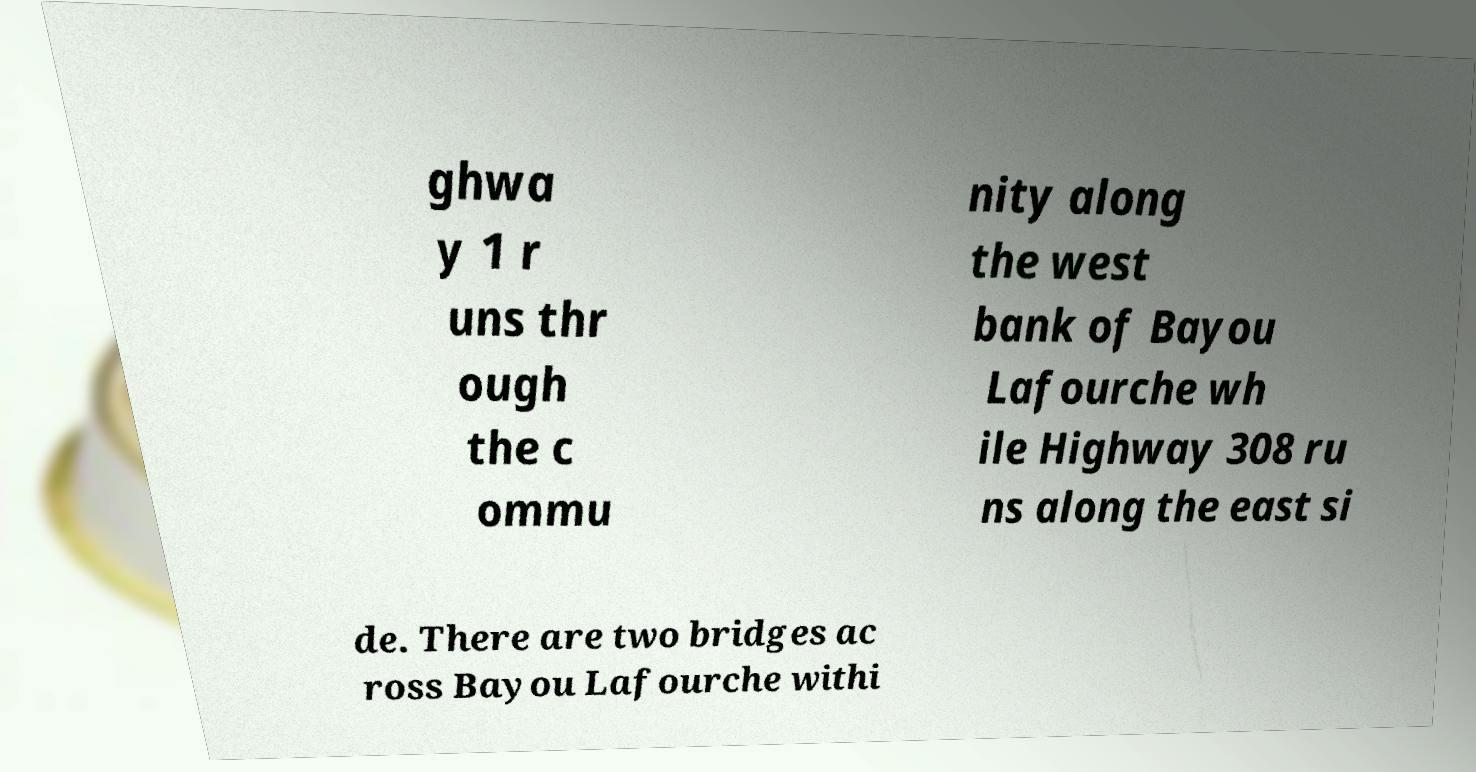What messages or text are displayed in this image? I need them in a readable, typed format. ghwa y 1 r uns thr ough the c ommu nity along the west bank of Bayou Lafourche wh ile Highway 308 ru ns along the east si de. There are two bridges ac ross Bayou Lafourche withi 